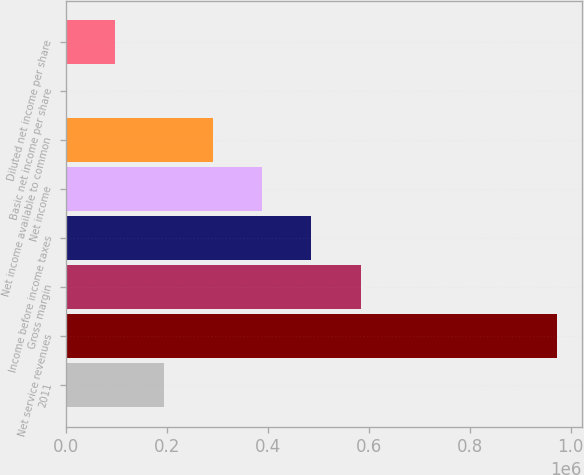Convert chart to OTSL. <chart><loc_0><loc_0><loc_500><loc_500><bar_chart><fcel>2011<fcel>Net service revenues<fcel>Gross margin<fcel>Income before income taxes<fcel>Net income<fcel>Net income available to common<fcel>Basic net income per share<fcel>Diluted net income per share<nl><fcel>194695<fcel>973473<fcel>584084<fcel>486737<fcel>389389<fcel>292042<fcel>0.3<fcel>97347.6<nl></chart> 